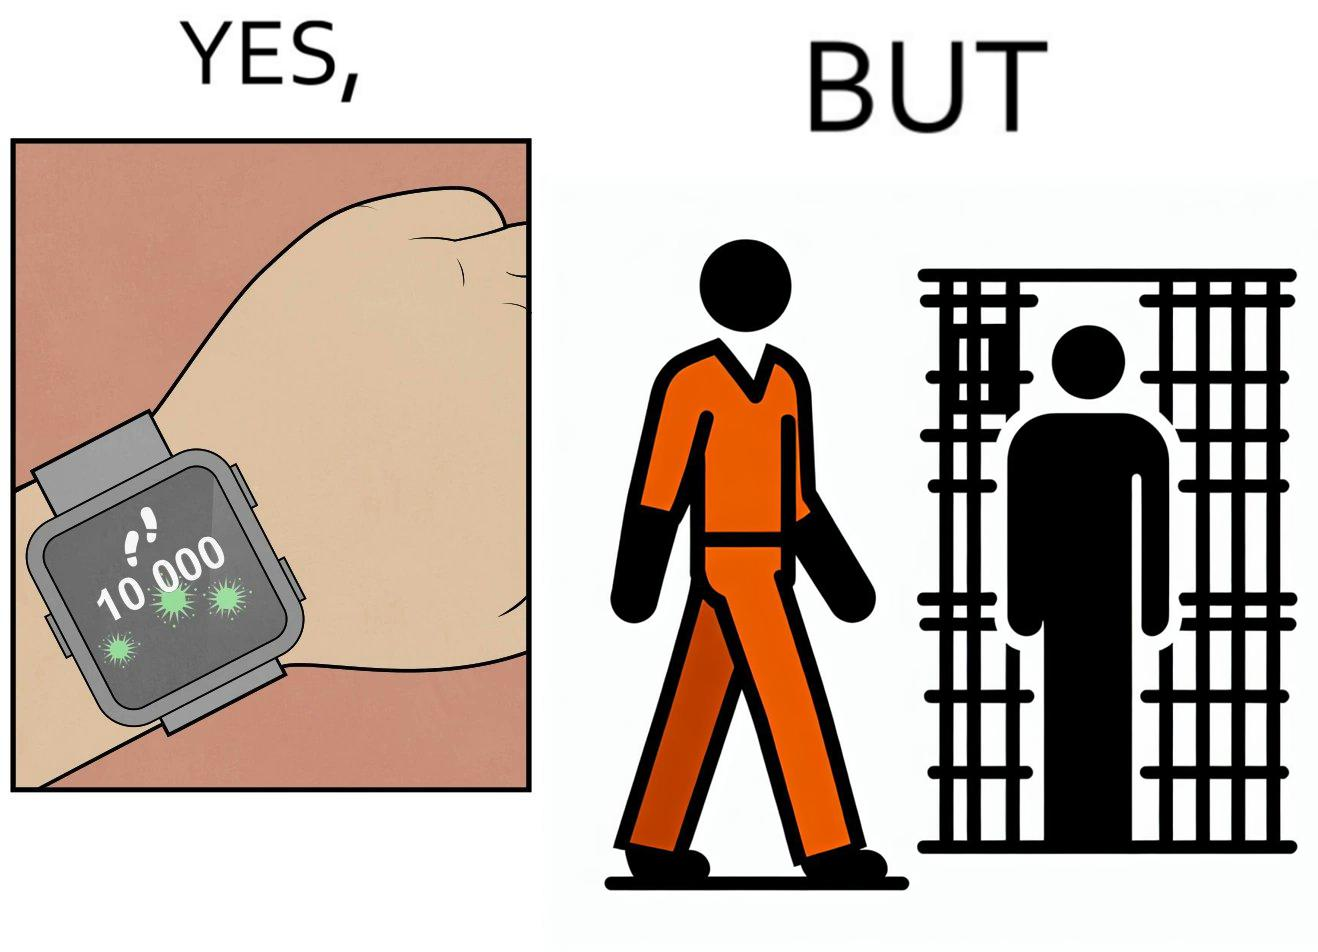Is this a satirical image? Yes, this image is satirical. 